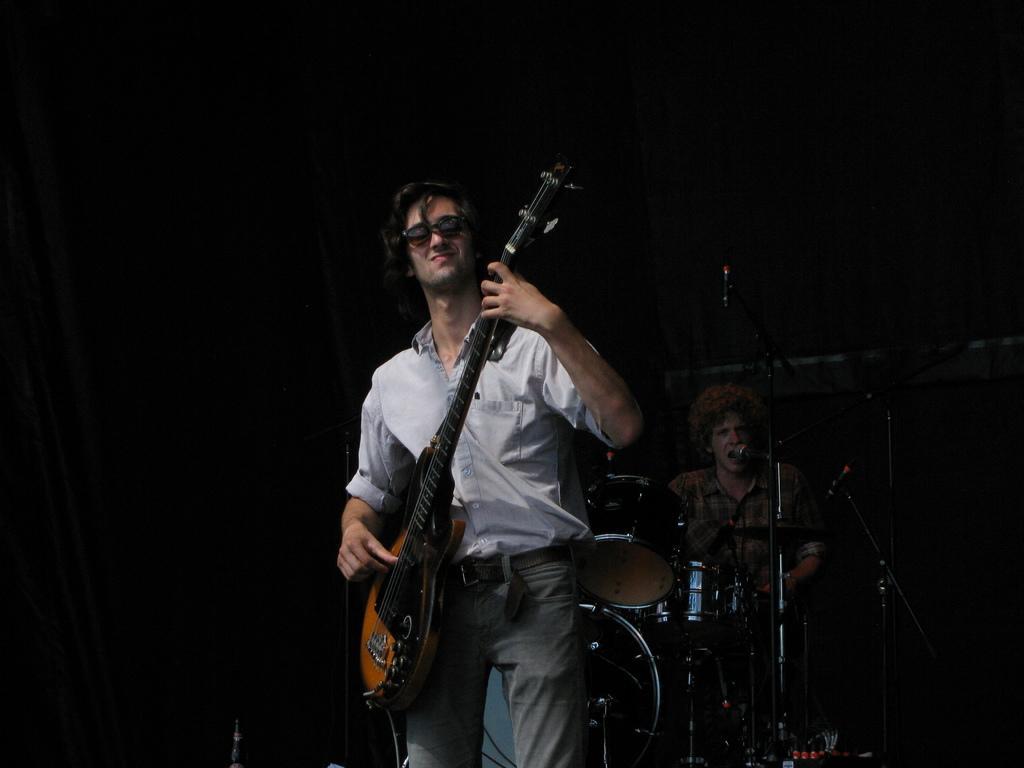Describe this image in one or two sentences. Here in the front we can see a person playing a guitar and behind him we can see another person playing drums and singing song with a microphone in front of him 